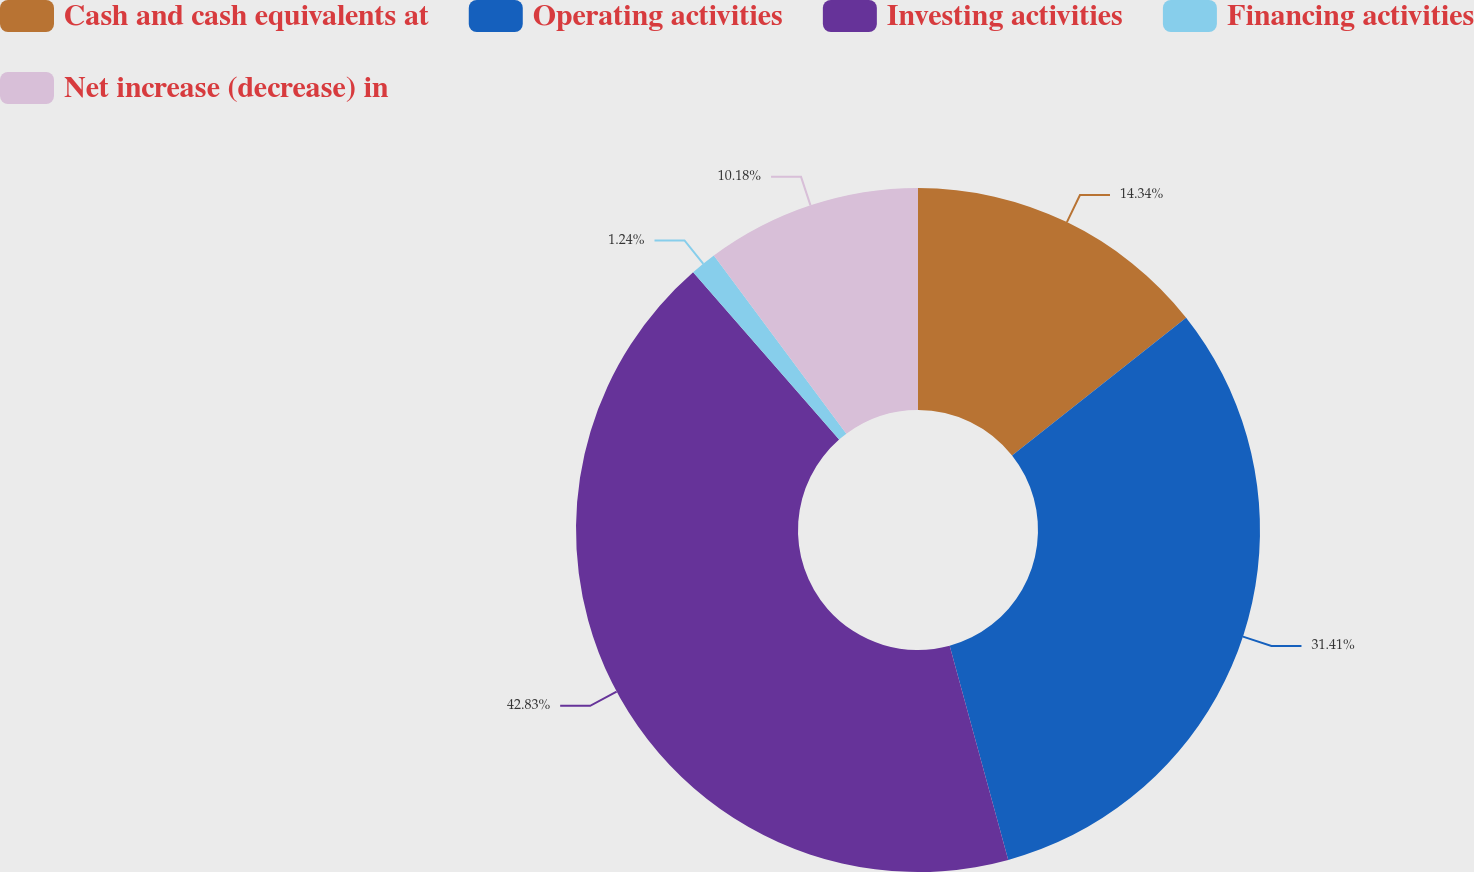Convert chart. <chart><loc_0><loc_0><loc_500><loc_500><pie_chart><fcel>Cash and cash equivalents at<fcel>Operating activities<fcel>Investing activities<fcel>Financing activities<fcel>Net increase (decrease) in<nl><fcel>14.34%<fcel>31.41%<fcel>42.83%<fcel>1.24%<fcel>10.18%<nl></chart> 